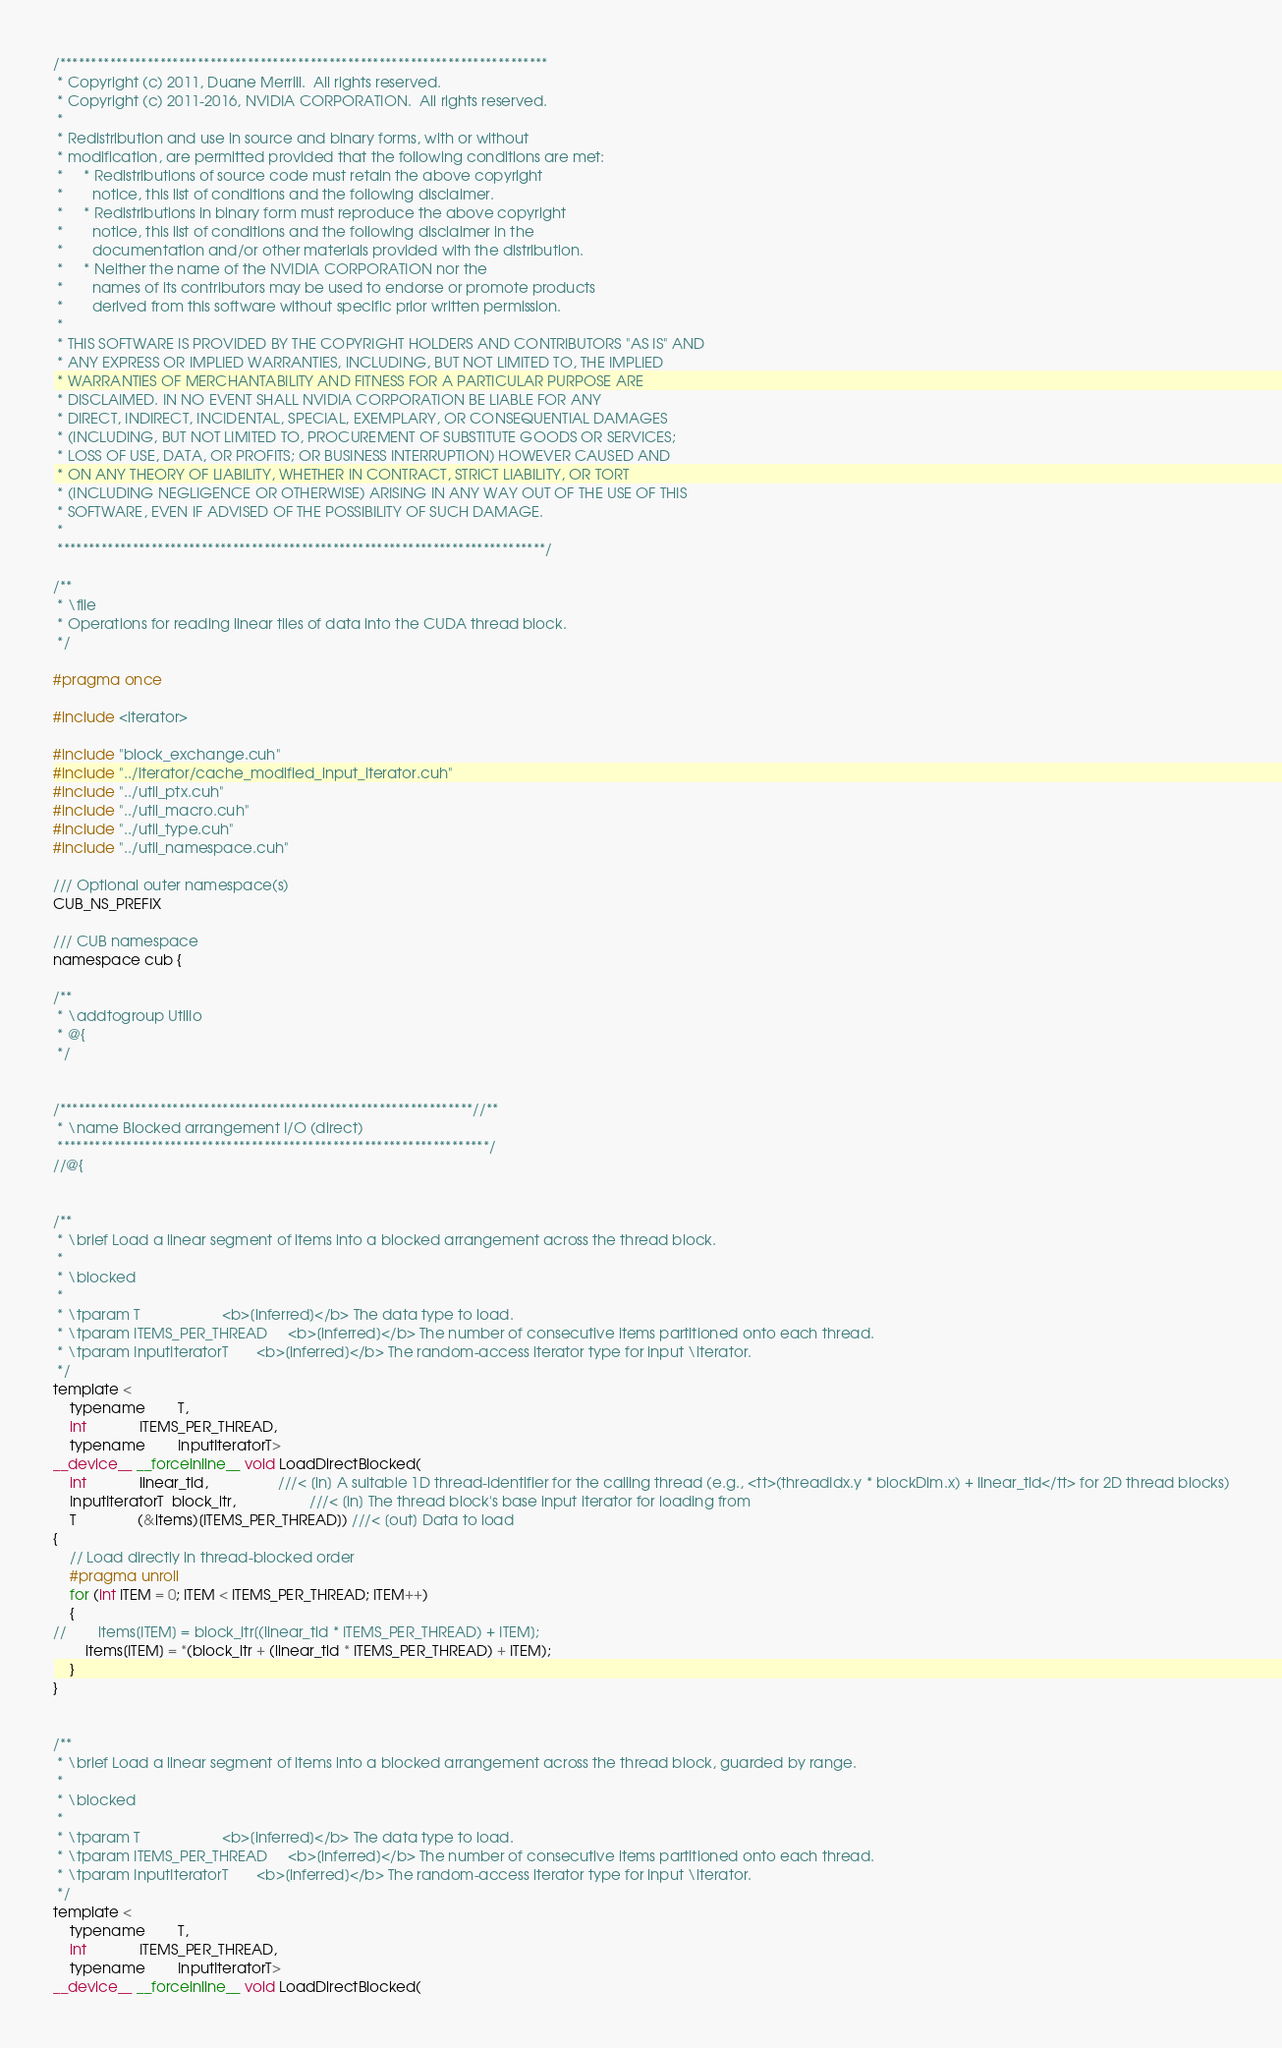Convert code to text. <code><loc_0><loc_0><loc_500><loc_500><_Cuda_>/******************************************************************************
 * Copyright (c) 2011, Duane Merrill.  All rights reserved.
 * Copyright (c) 2011-2016, NVIDIA CORPORATION.  All rights reserved.
 * 
 * Redistribution and use in source and binary forms, with or without
 * modification, are permitted provided that the following conditions are met:
 *     * Redistributions of source code must retain the above copyright
 *       notice, this list of conditions and the following disclaimer.
 *     * Redistributions in binary form must reproduce the above copyright
 *       notice, this list of conditions and the following disclaimer in the
 *       documentation and/or other materials provided with the distribution.
 *     * Neither the name of the NVIDIA CORPORATION nor the
 *       names of its contributors may be used to endorse or promote products
 *       derived from this software without specific prior written permission.
 * 
 * THIS SOFTWARE IS PROVIDED BY THE COPYRIGHT HOLDERS AND CONTRIBUTORS "AS IS" AND
 * ANY EXPRESS OR IMPLIED WARRANTIES, INCLUDING, BUT NOT LIMITED TO, THE IMPLIED
 * WARRANTIES OF MERCHANTABILITY AND FITNESS FOR A PARTICULAR PURPOSE ARE
 * DISCLAIMED. IN NO EVENT SHALL NVIDIA CORPORATION BE LIABLE FOR ANY
 * DIRECT, INDIRECT, INCIDENTAL, SPECIAL, EXEMPLARY, OR CONSEQUENTIAL DAMAGES
 * (INCLUDING, BUT NOT LIMITED TO, PROCUREMENT OF SUBSTITUTE GOODS OR SERVICES;
 * LOSS OF USE, DATA, OR PROFITS; OR BUSINESS INTERRUPTION) HOWEVER CAUSED AND
 * ON ANY THEORY OF LIABILITY, WHETHER IN CONTRACT, STRICT LIABILITY, OR TORT
 * (INCLUDING NEGLIGENCE OR OTHERWISE) ARISING IN ANY WAY OUT OF THE USE OF THIS
 * SOFTWARE, EVEN IF ADVISED OF THE POSSIBILITY OF SUCH DAMAGE.
 *
 ******************************************************************************/

/**
 * \file
 * Operations for reading linear tiles of data into the CUDA thread block.
 */

#pragma once

#include <iterator>

#include "block_exchange.cuh"
#include "../iterator/cache_modified_input_iterator.cuh"
#include "../util_ptx.cuh"
#include "../util_macro.cuh"
#include "../util_type.cuh"
#include "../util_namespace.cuh"

/// Optional outer namespace(s)
CUB_NS_PREFIX

/// CUB namespace
namespace cub {

/**
 * \addtogroup UtilIo
 * @{
 */


/******************************************************************//**
 * \name Blocked arrangement I/O (direct)
 *********************************************************************/
//@{


/**
 * \brief Load a linear segment of items into a blocked arrangement across the thread block.
 *
 * \blocked
 *
 * \tparam T                    <b>[inferred]</b> The data type to load.
 * \tparam ITEMS_PER_THREAD     <b>[inferred]</b> The number of consecutive items partitioned onto each thread.
 * \tparam InputIteratorT       <b>[inferred]</b> The random-access iterator type for input \iterator.
 */
template <
    typename        T,
    int             ITEMS_PER_THREAD,
    typename        InputIteratorT>
__device__ __forceinline__ void LoadDirectBlocked(
    int             linear_tid,                 ///< [in] A suitable 1D thread-identifier for the calling thread (e.g., <tt>(threadIdx.y * blockDim.x) + linear_tid</tt> for 2D thread blocks)
    InputIteratorT  block_itr,                  ///< [in] The thread block's base input iterator for loading from
    T               (&items)[ITEMS_PER_THREAD]) ///< [out] Data to load
{
    // Load directly in thread-blocked order
    #pragma unroll
    for (int ITEM = 0; ITEM < ITEMS_PER_THREAD; ITEM++)
    {
//        items[ITEM] = block_itr[(linear_tid * ITEMS_PER_THREAD) + ITEM];
        items[ITEM] = *(block_itr + (linear_tid * ITEMS_PER_THREAD) + ITEM);
    }
}


/**
 * \brief Load a linear segment of items into a blocked arrangement across the thread block, guarded by range.
 *
 * \blocked
 *
 * \tparam T                    <b>[inferred]</b> The data type to load.
 * \tparam ITEMS_PER_THREAD     <b>[inferred]</b> The number of consecutive items partitioned onto each thread.
 * \tparam InputIteratorT       <b>[inferred]</b> The random-access iterator type for input \iterator.
 */
template <
    typename        T,
    int             ITEMS_PER_THREAD,
    typename        InputIteratorT>
__device__ __forceinline__ void LoadDirectBlocked(</code> 